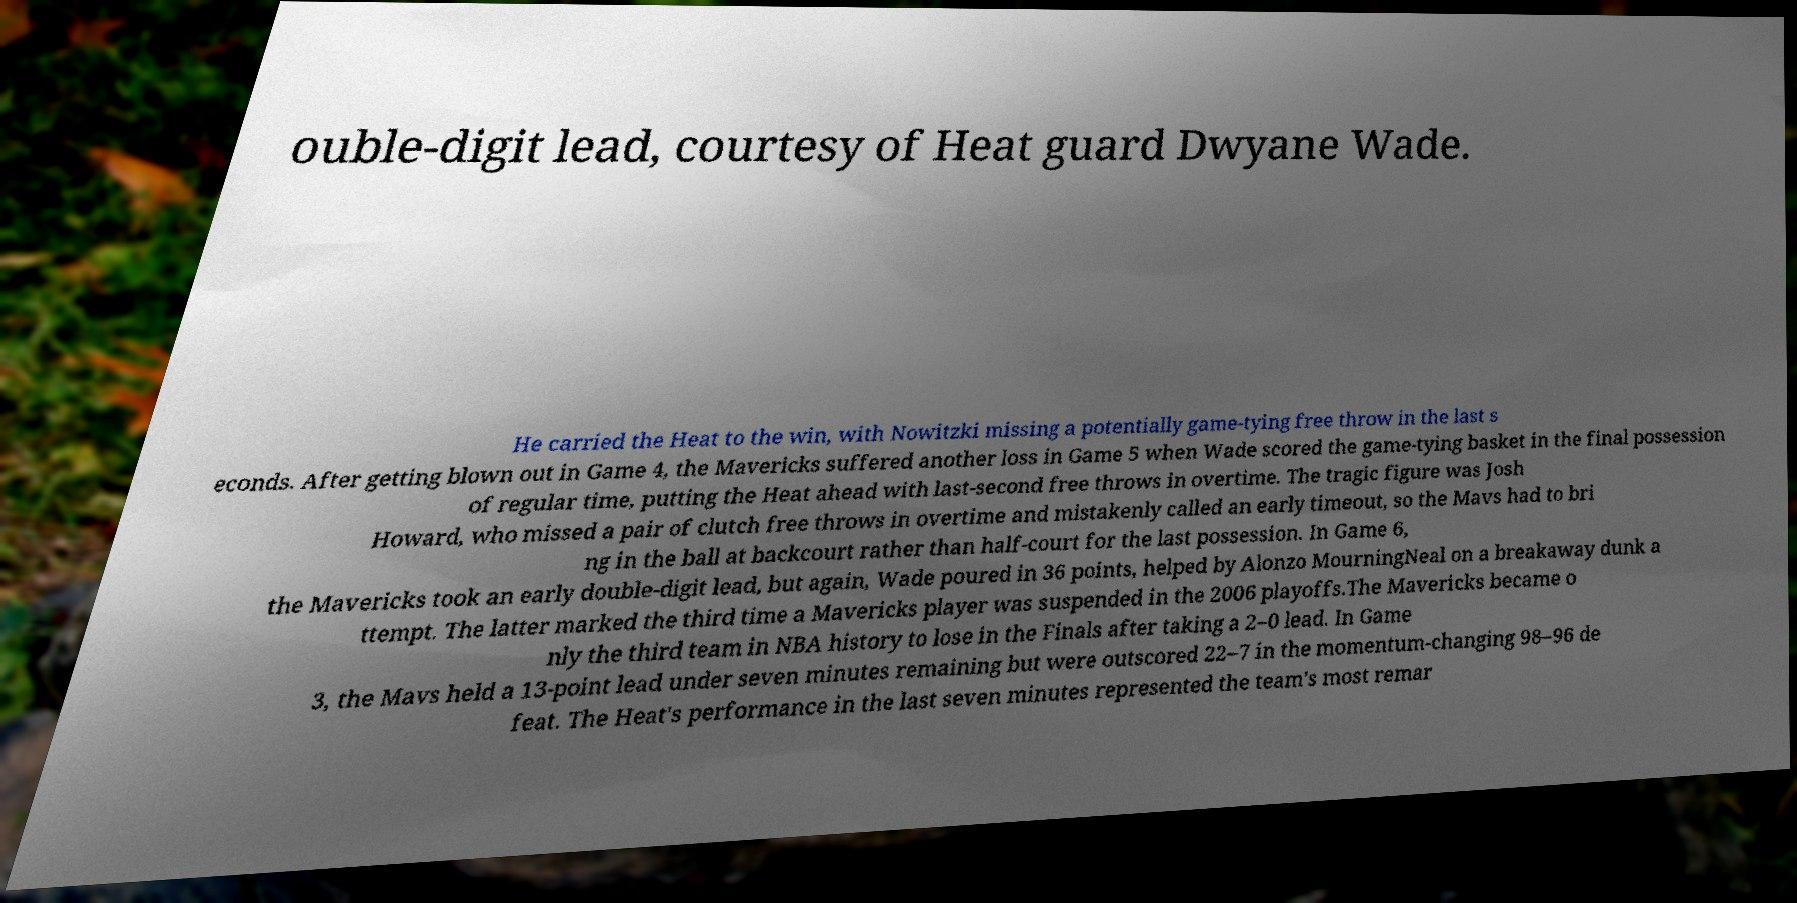Could you assist in decoding the text presented in this image and type it out clearly? ouble-digit lead, courtesy of Heat guard Dwyane Wade. He carried the Heat to the win, with Nowitzki missing a potentially game-tying free throw in the last s econds. After getting blown out in Game 4, the Mavericks suffered another loss in Game 5 when Wade scored the game-tying basket in the final possession of regular time, putting the Heat ahead with last-second free throws in overtime. The tragic figure was Josh Howard, who missed a pair of clutch free throws in overtime and mistakenly called an early timeout, so the Mavs had to bri ng in the ball at backcourt rather than half-court for the last possession. In Game 6, the Mavericks took an early double-digit lead, but again, Wade poured in 36 points, helped by Alonzo MourningNeal on a breakaway dunk a ttempt. The latter marked the third time a Mavericks player was suspended in the 2006 playoffs.The Mavericks became o nly the third team in NBA history to lose in the Finals after taking a 2–0 lead. In Game 3, the Mavs held a 13-point lead under seven minutes remaining but were outscored 22–7 in the momentum-changing 98–96 de feat. The Heat's performance in the last seven minutes represented the team's most remar 